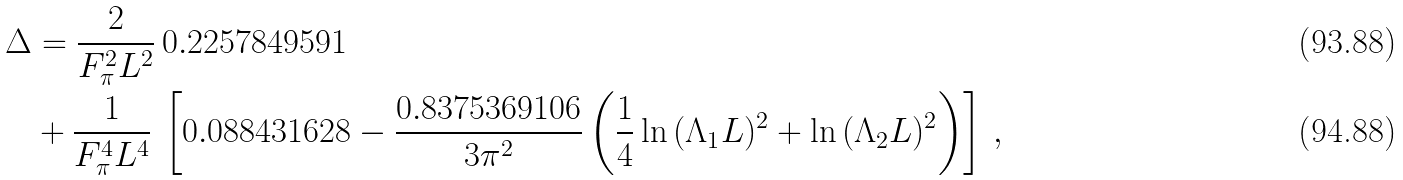Convert formula to latex. <formula><loc_0><loc_0><loc_500><loc_500>\Delta & = \frac { 2 } { F _ { \pi } ^ { 2 } L ^ { 2 } } \, 0 . 2 2 5 7 8 4 9 5 9 1 \\ & + \frac { 1 } { F _ { \pi } ^ { 4 } L ^ { 4 } } \, \left [ 0 . 0 8 8 4 3 1 6 2 8 - \frac { 0 . 8 3 7 5 3 6 9 1 0 6 } { 3 \pi ^ { 2 } } \left ( \frac { 1 } { 4 } \ln { ( \Lambda _ { 1 } L ) ^ { 2 } } + \ln { ( \Lambda _ { 2 } L ) ^ { 2 } } \right ) \right ] \, ,</formula> 